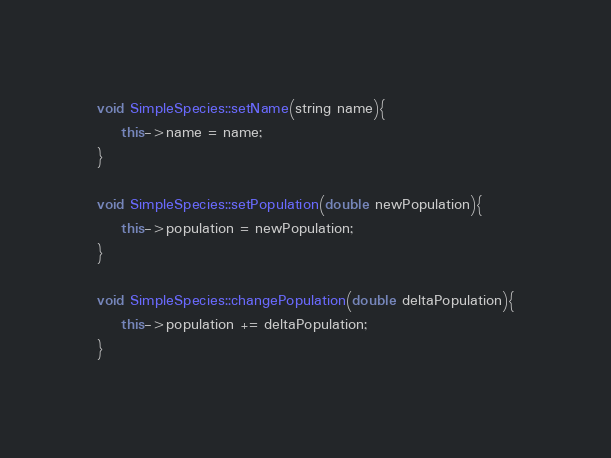<code> <loc_0><loc_0><loc_500><loc_500><_C++_>
void SimpleSpecies::setName(string name){
	this->name = name;
}

void SimpleSpecies::setPopulation(double newPopulation){
	this->population = newPopulation;
}

void SimpleSpecies::changePopulation(double deltaPopulation){
	this->population += deltaPopulation;
}
</code> 